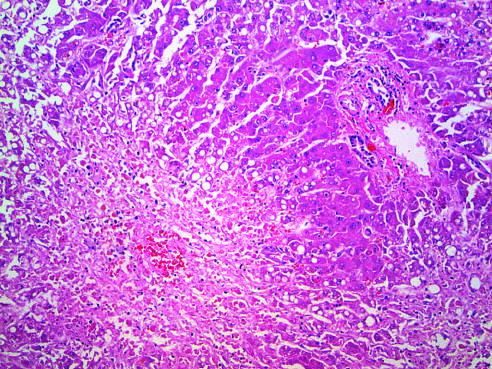s there little inflammation?
Answer the question using a single word or phrase. Yes 